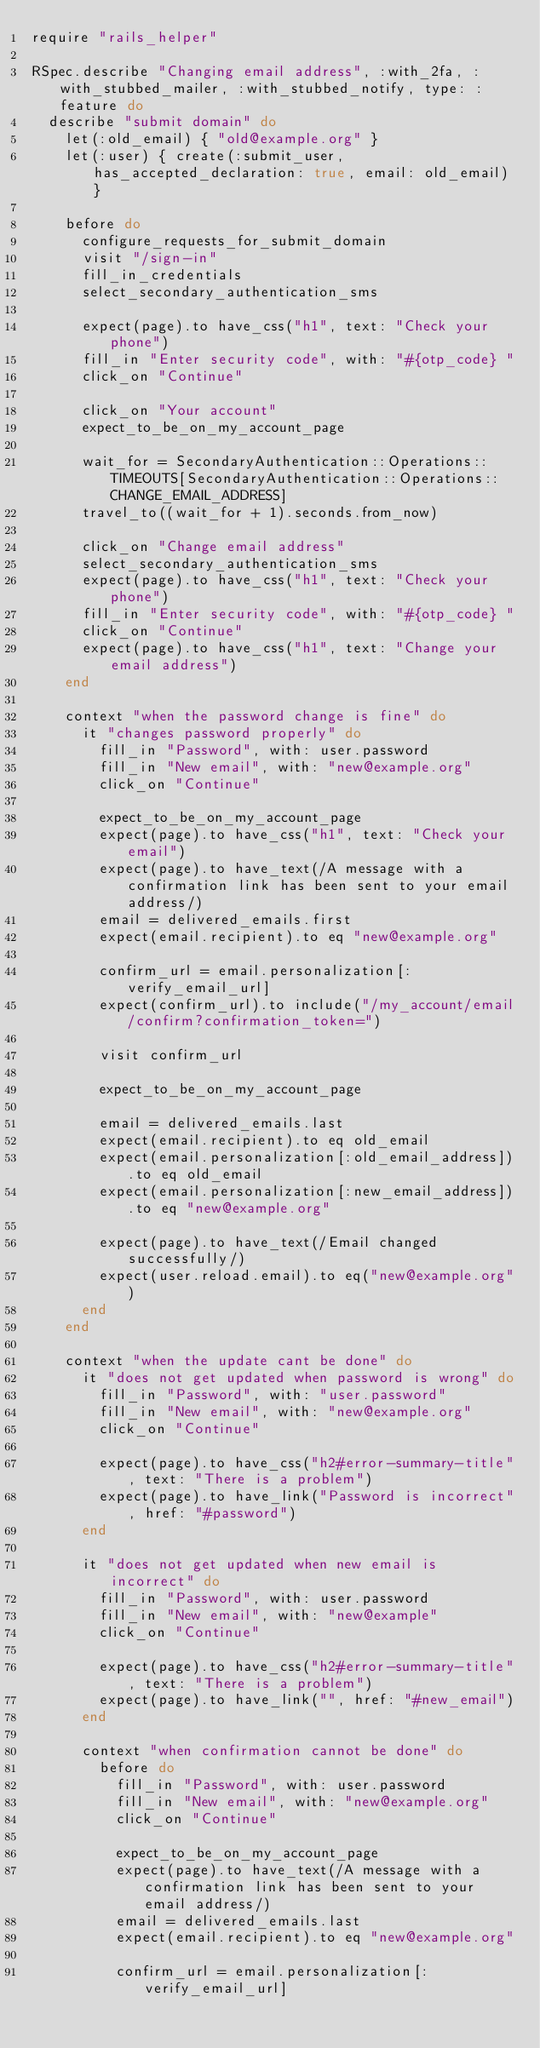Convert code to text. <code><loc_0><loc_0><loc_500><loc_500><_Ruby_>require "rails_helper"

RSpec.describe "Changing email address", :with_2fa, :with_stubbed_mailer, :with_stubbed_notify, type: :feature do
  describe "submit domain" do
    let(:old_email) { "old@example.org" }
    let(:user) { create(:submit_user, has_accepted_declaration: true, email: old_email) }

    before do
      configure_requests_for_submit_domain
      visit "/sign-in"
      fill_in_credentials
      select_secondary_authentication_sms

      expect(page).to have_css("h1", text: "Check your phone")
      fill_in "Enter security code", with: "#{otp_code} "
      click_on "Continue"

      click_on "Your account"
      expect_to_be_on_my_account_page

      wait_for = SecondaryAuthentication::Operations::TIMEOUTS[SecondaryAuthentication::Operations::CHANGE_EMAIL_ADDRESS]
      travel_to((wait_for + 1).seconds.from_now)

      click_on "Change email address"
      select_secondary_authentication_sms
      expect(page).to have_css("h1", text: "Check your phone")
      fill_in "Enter security code", with: "#{otp_code} "
      click_on "Continue"
      expect(page).to have_css("h1", text: "Change your email address")
    end

    context "when the password change is fine" do
      it "changes password properly" do
        fill_in "Password", with: user.password
        fill_in "New email", with: "new@example.org"
        click_on "Continue"

        expect_to_be_on_my_account_page
        expect(page).to have_css("h1", text: "Check your email")
        expect(page).to have_text(/A message with a confirmation link has been sent to your email address/)
        email = delivered_emails.first
        expect(email.recipient).to eq "new@example.org"

        confirm_url = email.personalization[:verify_email_url]
        expect(confirm_url).to include("/my_account/email/confirm?confirmation_token=")

        visit confirm_url

        expect_to_be_on_my_account_page

        email = delivered_emails.last
        expect(email.recipient).to eq old_email
        expect(email.personalization[:old_email_address]).to eq old_email
        expect(email.personalization[:new_email_address]).to eq "new@example.org"

        expect(page).to have_text(/Email changed successfully/)
        expect(user.reload.email).to eq("new@example.org")
      end
    end

    context "when the update cant be done" do
      it "does not get updated when password is wrong" do
        fill_in "Password", with: "user.password"
        fill_in "New email", with: "new@example.org"
        click_on "Continue"

        expect(page).to have_css("h2#error-summary-title", text: "There is a problem")
        expect(page).to have_link("Password is incorrect", href: "#password")
      end

      it "does not get updated when new email is incorrect" do
        fill_in "Password", with: user.password
        fill_in "New email", with: "new@example"
        click_on "Continue"

        expect(page).to have_css("h2#error-summary-title", text: "There is a problem")
        expect(page).to have_link("", href: "#new_email")
      end

      context "when confirmation cannot be done" do
        before do
          fill_in "Password", with: user.password
          fill_in "New email", with: "new@example.org"
          click_on "Continue"

          expect_to_be_on_my_account_page
          expect(page).to have_text(/A message with a confirmation link has been sent to your email address/)
          email = delivered_emails.last
          expect(email.recipient).to eq "new@example.org"

          confirm_url = email.personalization[:verify_email_url]</code> 